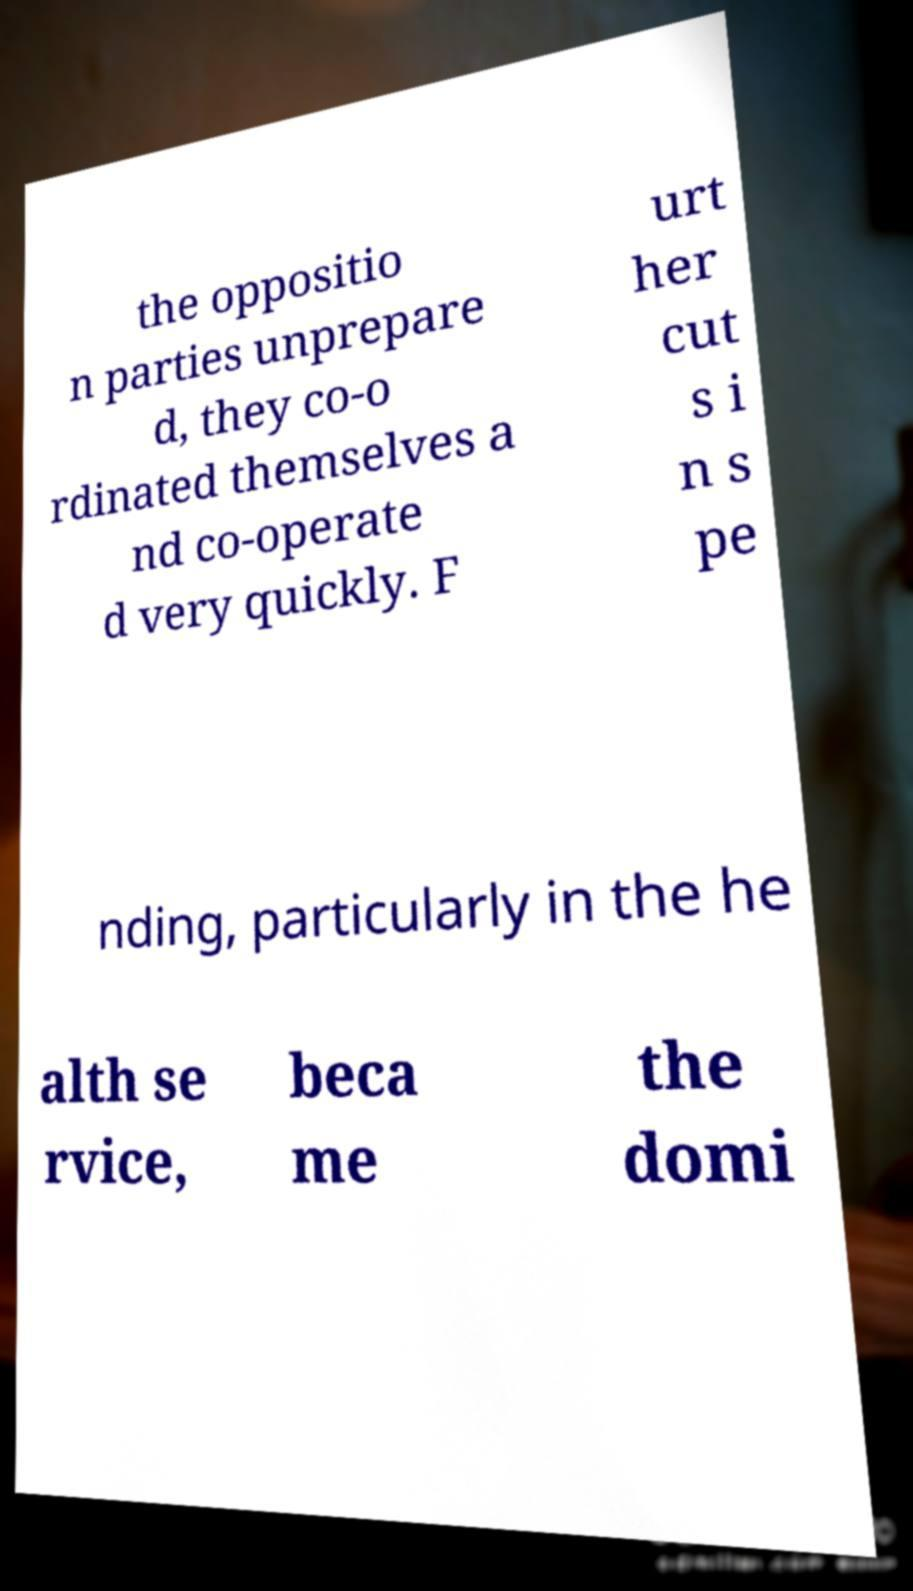Can you accurately transcribe the text from the provided image for me? the oppositio n parties unprepare d, they co-o rdinated themselves a nd co-operate d very quickly. F urt her cut s i n s pe nding, particularly in the he alth se rvice, beca me the domi 